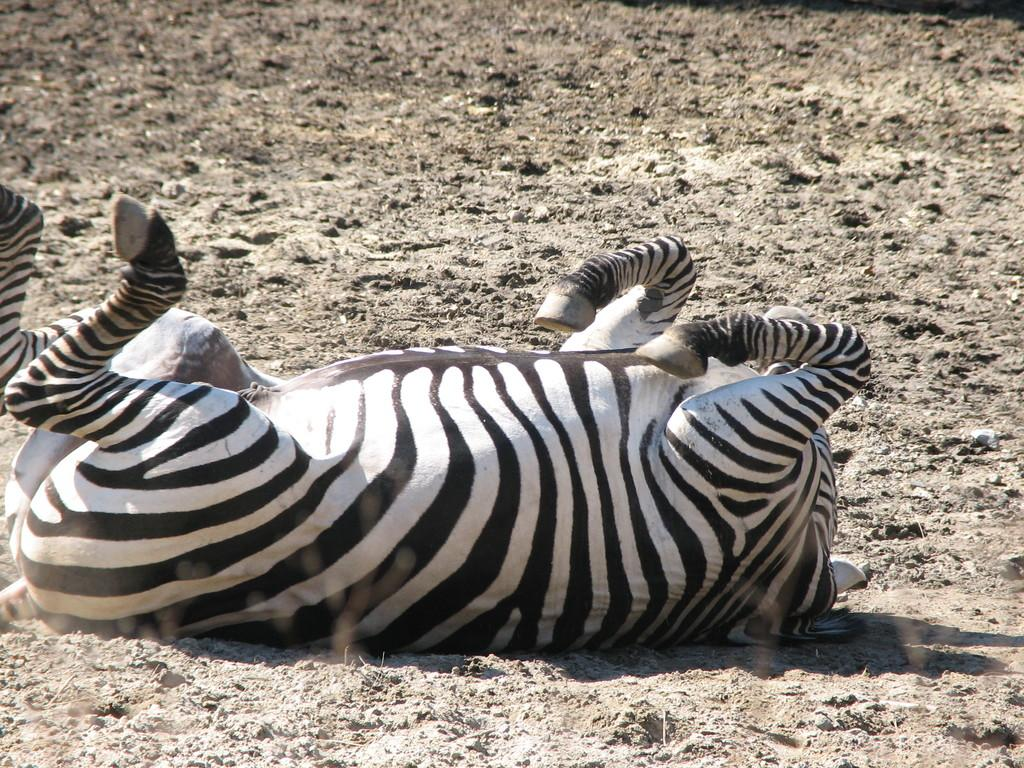What animal is present in the image? There is a zebra in the image. Where is the zebra located? The zebra is on the ground. What is the color pattern of the zebra? The zebra has a white and black color pattern. What type of disgust can be seen on the zebra's face in the image? There is no indication of disgust on the zebra's face in the image, as it is a photograph of an animal and does not convey emotions. 